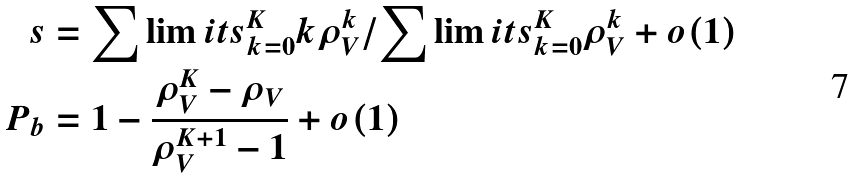Convert formula to latex. <formula><loc_0><loc_0><loc_500><loc_500>s & = \sum \lim i t s _ { k = 0 } ^ { K } k \rho _ { V } ^ { k } / \sum \lim i t s _ { k = 0 } ^ { K } \rho _ { V } ^ { k } + o ( 1 ) \\ P _ { b } & = 1 - \frac { \rho _ { V } ^ { K } - \rho _ { V } } { \rho _ { V } ^ { K + 1 } - 1 } + o ( 1 )</formula> 